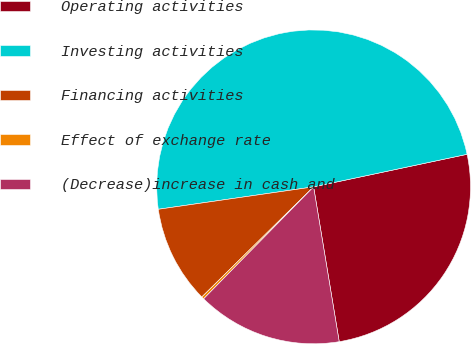<chart> <loc_0><loc_0><loc_500><loc_500><pie_chart><fcel>Operating activities<fcel>Investing activities<fcel>Financing activities<fcel>Effect of exchange rate<fcel>(Decrease)increase in cash and<nl><fcel>25.72%<fcel>48.96%<fcel>10.1%<fcel>0.26%<fcel>14.97%<nl></chart> 